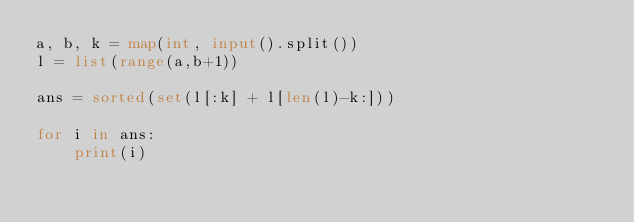<code> <loc_0><loc_0><loc_500><loc_500><_Python_>a, b, k = map(int, input().split())
l = list(range(a,b+1))

ans = sorted(set(l[:k] + l[len(l)-k:]))

for i in ans:
    print(i)</code> 